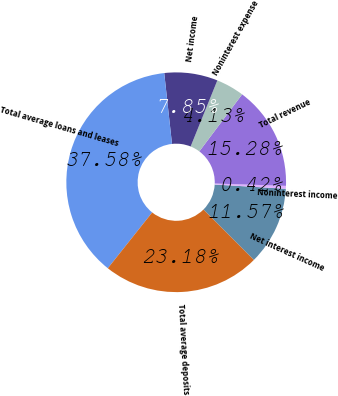Convert chart. <chart><loc_0><loc_0><loc_500><loc_500><pie_chart><fcel>Net interest income<fcel>Noninterest income<fcel>Total revenue<fcel>Noninterest expense<fcel>Net income<fcel>Total average loans and leases<fcel>Total average deposits<nl><fcel>11.57%<fcel>0.42%<fcel>15.28%<fcel>4.13%<fcel>7.85%<fcel>37.58%<fcel>23.18%<nl></chart> 